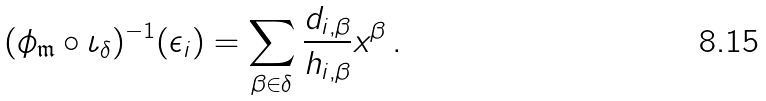Convert formula to latex. <formula><loc_0><loc_0><loc_500><loc_500>( \phi _ { \mathfrak { m } } \circ \iota _ { \delta } ) ^ { - 1 } ( \epsilon _ { i } ) = \sum _ { \beta \in \delta } \frac { d _ { i , \beta } } { h _ { i , \beta } } x ^ { \beta } \, .</formula> 